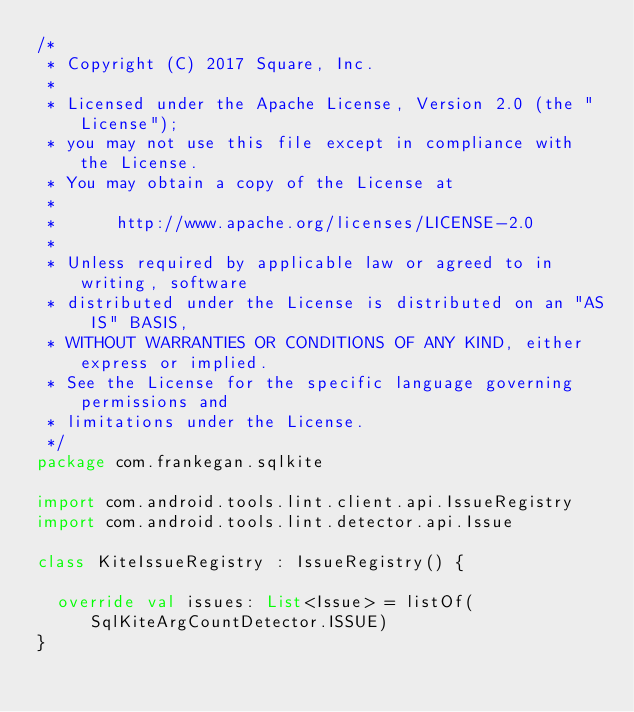<code> <loc_0><loc_0><loc_500><loc_500><_Kotlin_>/*
 * Copyright (C) 2017 Square, Inc.
 *
 * Licensed under the Apache License, Version 2.0 (the "License");
 * you may not use this file except in compliance with the License.
 * You may obtain a copy of the License at
 *
 *      http://www.apache.org/licenses/LICENSE-2.0
 *
 * Unless required by applicable law or agreed to in writing, software
 * distributed under the License is distributed on an "AS IS" BASIS,
 * WITHOUT WARRANTIES OR CONDITIONS OF ANY KIND, either express or implied.
 * See the License for the specific language governing permissions and
 * limitations under the License.
 */
package com.frankegan.sqlkite

import com.android.tools.lint.client.api.IssueRegistry
import com.android.tools.lint.detector.api.Issue

class KiteIssueRegistry : IssueRegistry() {

  override val issues: List<Issue> = listOf(SqlKiteArgCountDetector.ISSUE)
}
</code> 